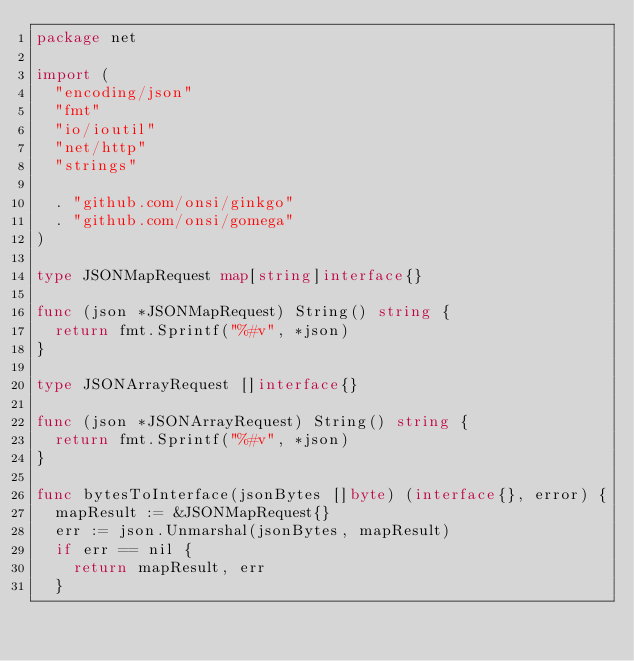<code> <loc_0><loc_0><loc_500><loc_500><_Go_>package net

import (
	"encoding/json"
	"fmt"
	"io/ioutil"
	"net/http"
	"strings"

	. "github.com/onsi/ginkgo"
	. "github.com/onsi/gomega"
)

type JSONMapRequest map[string]interface{}

func (json *JSONMapRequest) String() string {
	return fmt.Sprintf("%#v", *json)
}

type JSONArrayRequest []interface{}

func (json *JSONArrayRequest) String() string {
	return fmt.Sprintf("%#v", *json)
}

func bytesToInterface(jsonBytes []byte) (interface{}, error) {
	mapResult := &JSONMapRequest{}
	err := json.Unmarshal(jsonBytes, mapResult)
	if err == nil {
		return mapResult, err
	}
</code> 